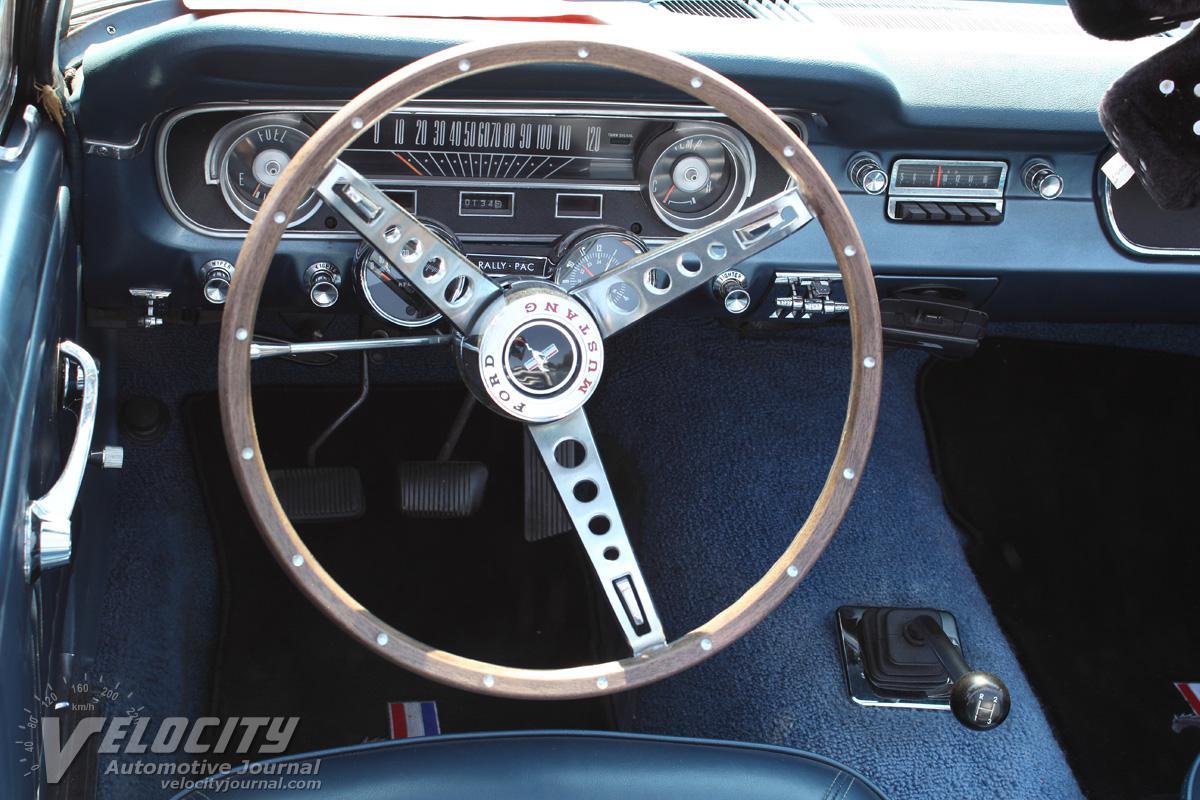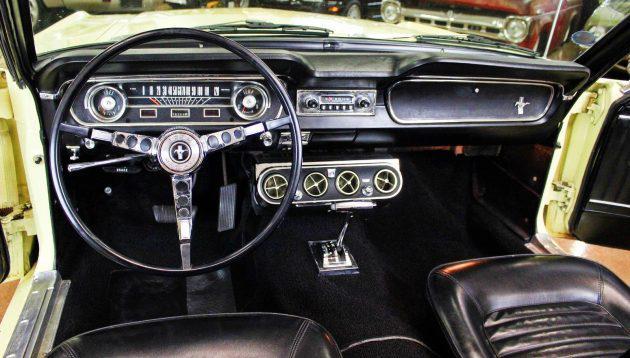The first image is the image on the left, the second image is the image on the right. For the images shown, is this caption "One of the images has a red Ford Mustang convertible." true? Answer yes or no. No. 